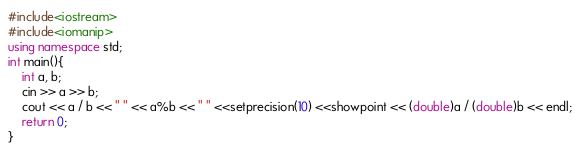Convert code to text. <code><loc_0><loc_0><loc_500><loc_500><_C++_>#include<iostream>
#include<iomanip>
using namespace std;
int main(){
	int a, b;
	cin >> a >> b;
	cout << a / b << " " << a%b << " " <<setprecision(10) <<showpoint << (double)a / (double)b << endl;
	return 0;
}</code> 